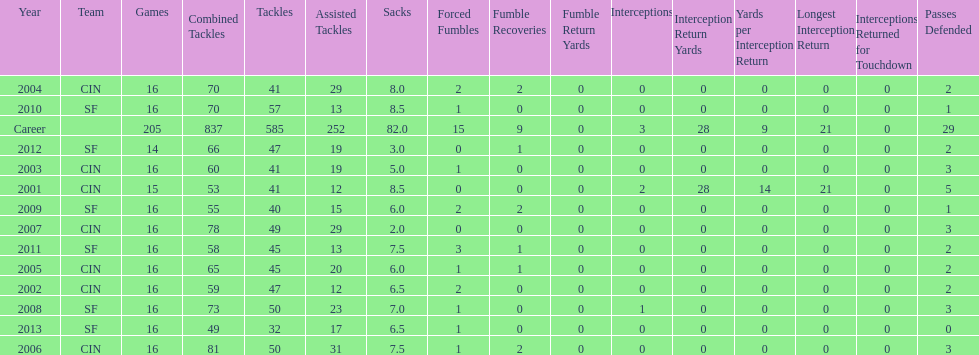How many fumble recoveries did this player have in 2004? 2. 